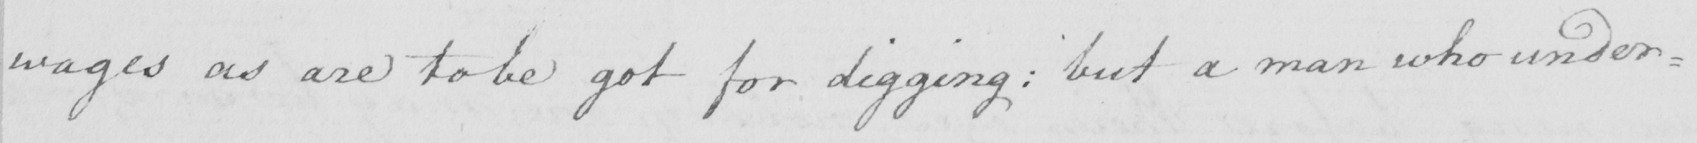Transcribe the text shown in this historical manuscript line. wages as are to be got for digging :  but a man who under= 